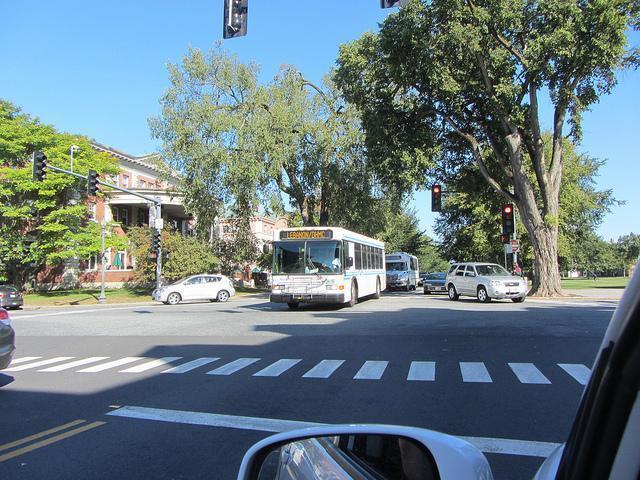How many cars are there?
Give a very brief answer. 2. 